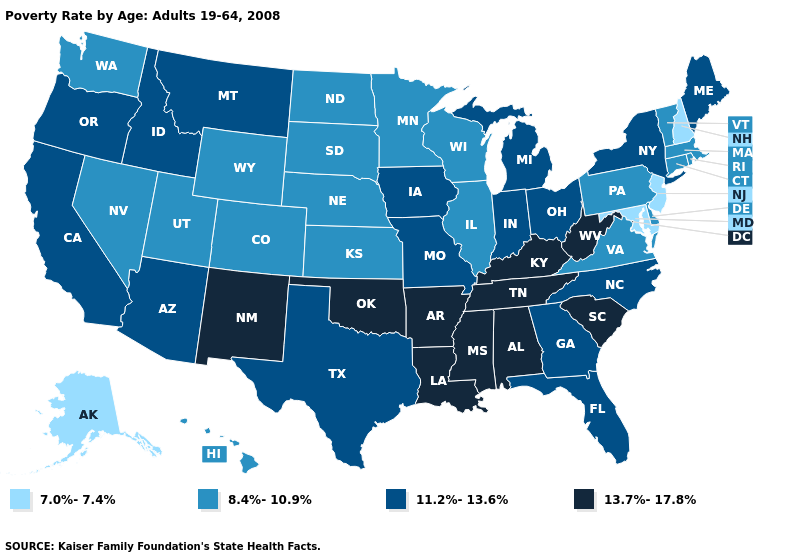Name the states that have a value in the range 7.0%-7.4%?
Short answer required. Alaska, Maryland, New Hampshire, New Jersey. Among the states that border Maryland , which have the lowest value?
Write a very short answer. Delaware, Pennsylvania, Virginia. Name the states that have a value in the range 7.0%-7.4%?
Keep it brief. Alaska, Maryland, New Hampshire, New Jersey. What is the lowest value in the MidWest?
Answer briefly. 8.4%-10.9%. Does Arizona have a higher value than Utah?
Be succinct. Yes. Is the legend a continuous bar?
Give a very brief answer. No. What is the lowest value in states that border South Dakota?
Answer briefly. 8.4%-10.9%. Name the states that have a value in the range 11.2%-13.6%?
Write a very short answer. Arizona, California, Florida, Georgia, Idaho, Indiana, Iowa, Maine, Michigan, Missouri, Montana, New York, North Carolina, Ohio, Oregon, Texas. Which states have the lowest value in the USA?
Be succinct. Alaska, Maryland, New Hampshire, New Jersey. What is the value of Maryland?
Short answer required. 7.0%-7.4%. What is the highest value in the South ?
Concise answer only. 13.7%-17.8%. Among the states that border Ohio , which have the lowest value?
Short answer required. Pennsylvania. What is the highest value in the USA?
Short answer required. 13.7%-17.8%. Does Minnesota have a higher value than New Jersey?
Quick response, please. Yes. 